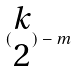Convert formula to latex. <formula><loc_0><loc_0><loc_500><loc_500>( \begin{matrix} k \\ 2 \end{matrix} ) - m</formula> 